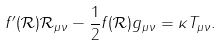<formula> <loc_0><loc_0><loc_500><loc_500>f ^ { \prime } ( \mathcal { R } ) \mathcal { R } _ { \mu \nu } - \frac { 1 } { 2 } f ( \mathcal { R } ) g _ { \mu \nu } = \kappa T _ { \mu \nu } .</formula> 